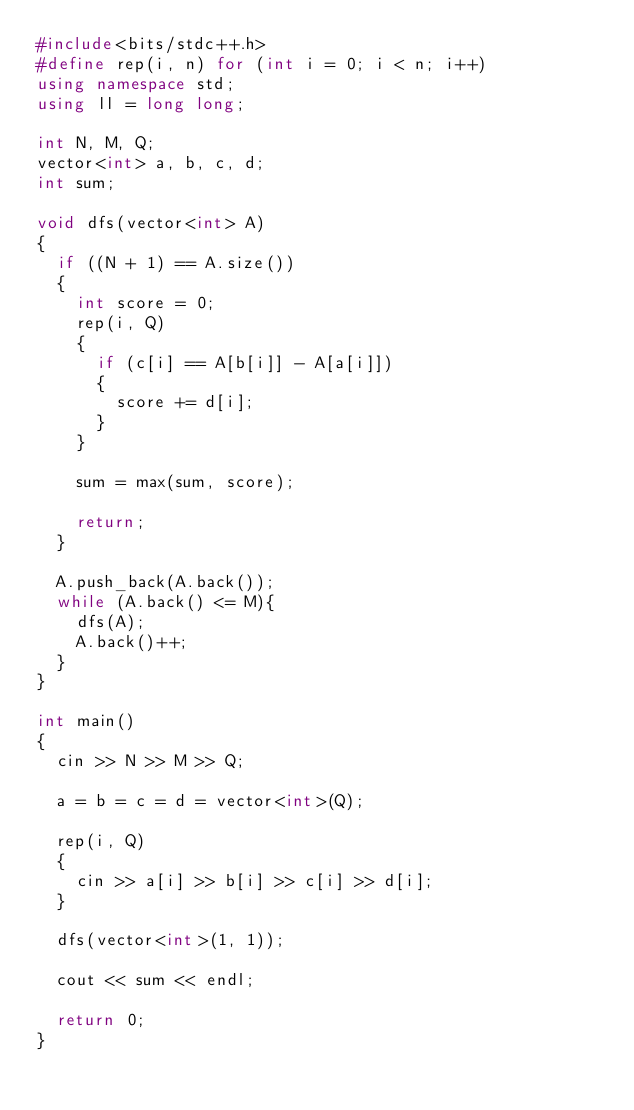Convert code to text. <code><loc_0><loc_0><loc_500><loc_500><_C++_>#include<bits/stdc++.h>
#define rep(i, n) for (int i = 0; i < n; i++)
using namespace std;
using ll = long long;

int N, M, Q;
vector<int> a, b, c, d;
int sum;

void dfs(vector<int> A)
{
  if ((N + 1) == A.size())
  {
    int score = 0;
    rep(i, Q)
    {
      if (c[i] == A[b[i]] - A[a[i]])
      {
        score += d[i];
      }
    }
    
    sum = max(sum, score);
    
    return;
  }
  
  A.push_back(A.back());
  while (A.back() <= M){
    dfs(A);
    A.back()++;
  }
}

int main()
{
  cin >> N >> M >> Q;
  
  a = b = c = d = vector<int>(Q);
  
  rep(i, Q)
  {
    cin >> a[i] >> b[i] >> c[i] >> d[i];
  }
  
  dfs(vector<int>(1, 1));
  
  cout << sum << endl;

  return 0;
}</code> 